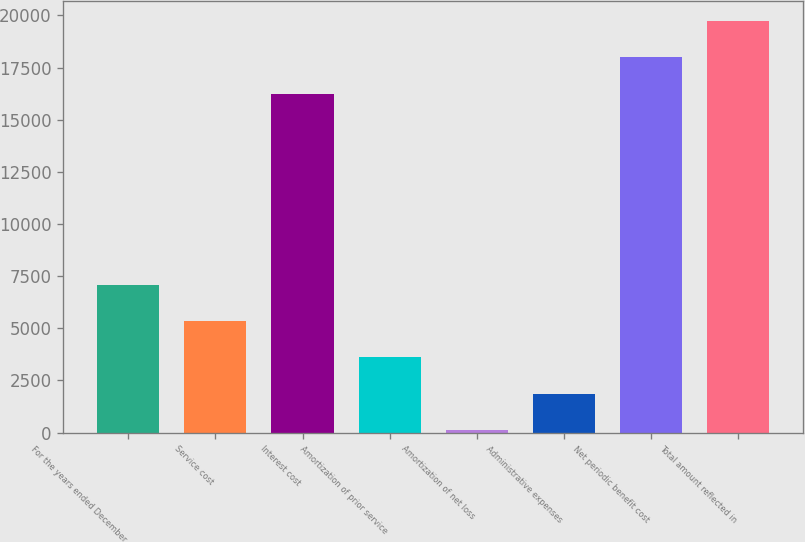<chart> <loc_0><loc_0><loc_500><loc_500><bar_chart><fcel>For the years ended December<fcel>Service cost<fcel>Interest cost<fcel>Amortization of prior service<fcel>Amortization of net loss<fcel>Administrative expenses<fcel>Net periodic benefit cost<fcel>Total amount reflected in<nl><fcel>7075.8<fcel>5340.6<fcel>16254<fcel>3605.4<fcel>135<fcel>1870.2<fcel>17989.2<fcel>19724.4<nl></chart> 